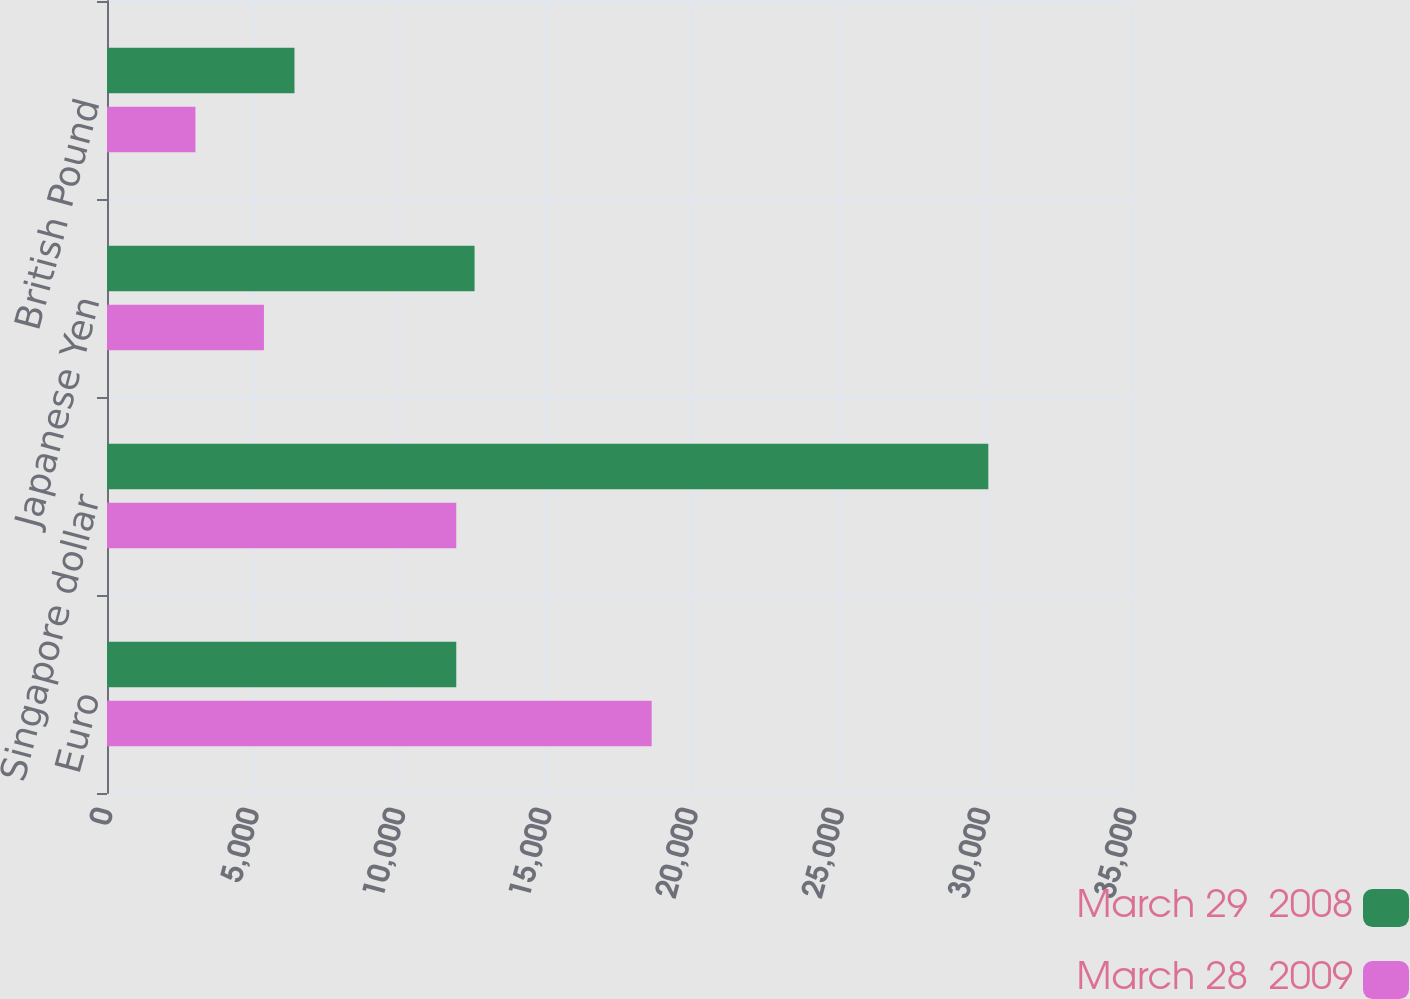Convert chart to OTSL. <chart><loc_0><loc_0><loc_500><loc_500><stacked_bar_chart><ecel><fcel>Euro<fcel>Singapore dollar<fcel>Japanese Yen<fcel>British Pound<nl><fcel>March 29  2008<fcel>11938<fcel>30123<fcel>12563<fcel>6408<nl><fcel>March 28  2009<fcel>18616<fcel>11938<fcel>5364<fcel>3022<nl></chart> 